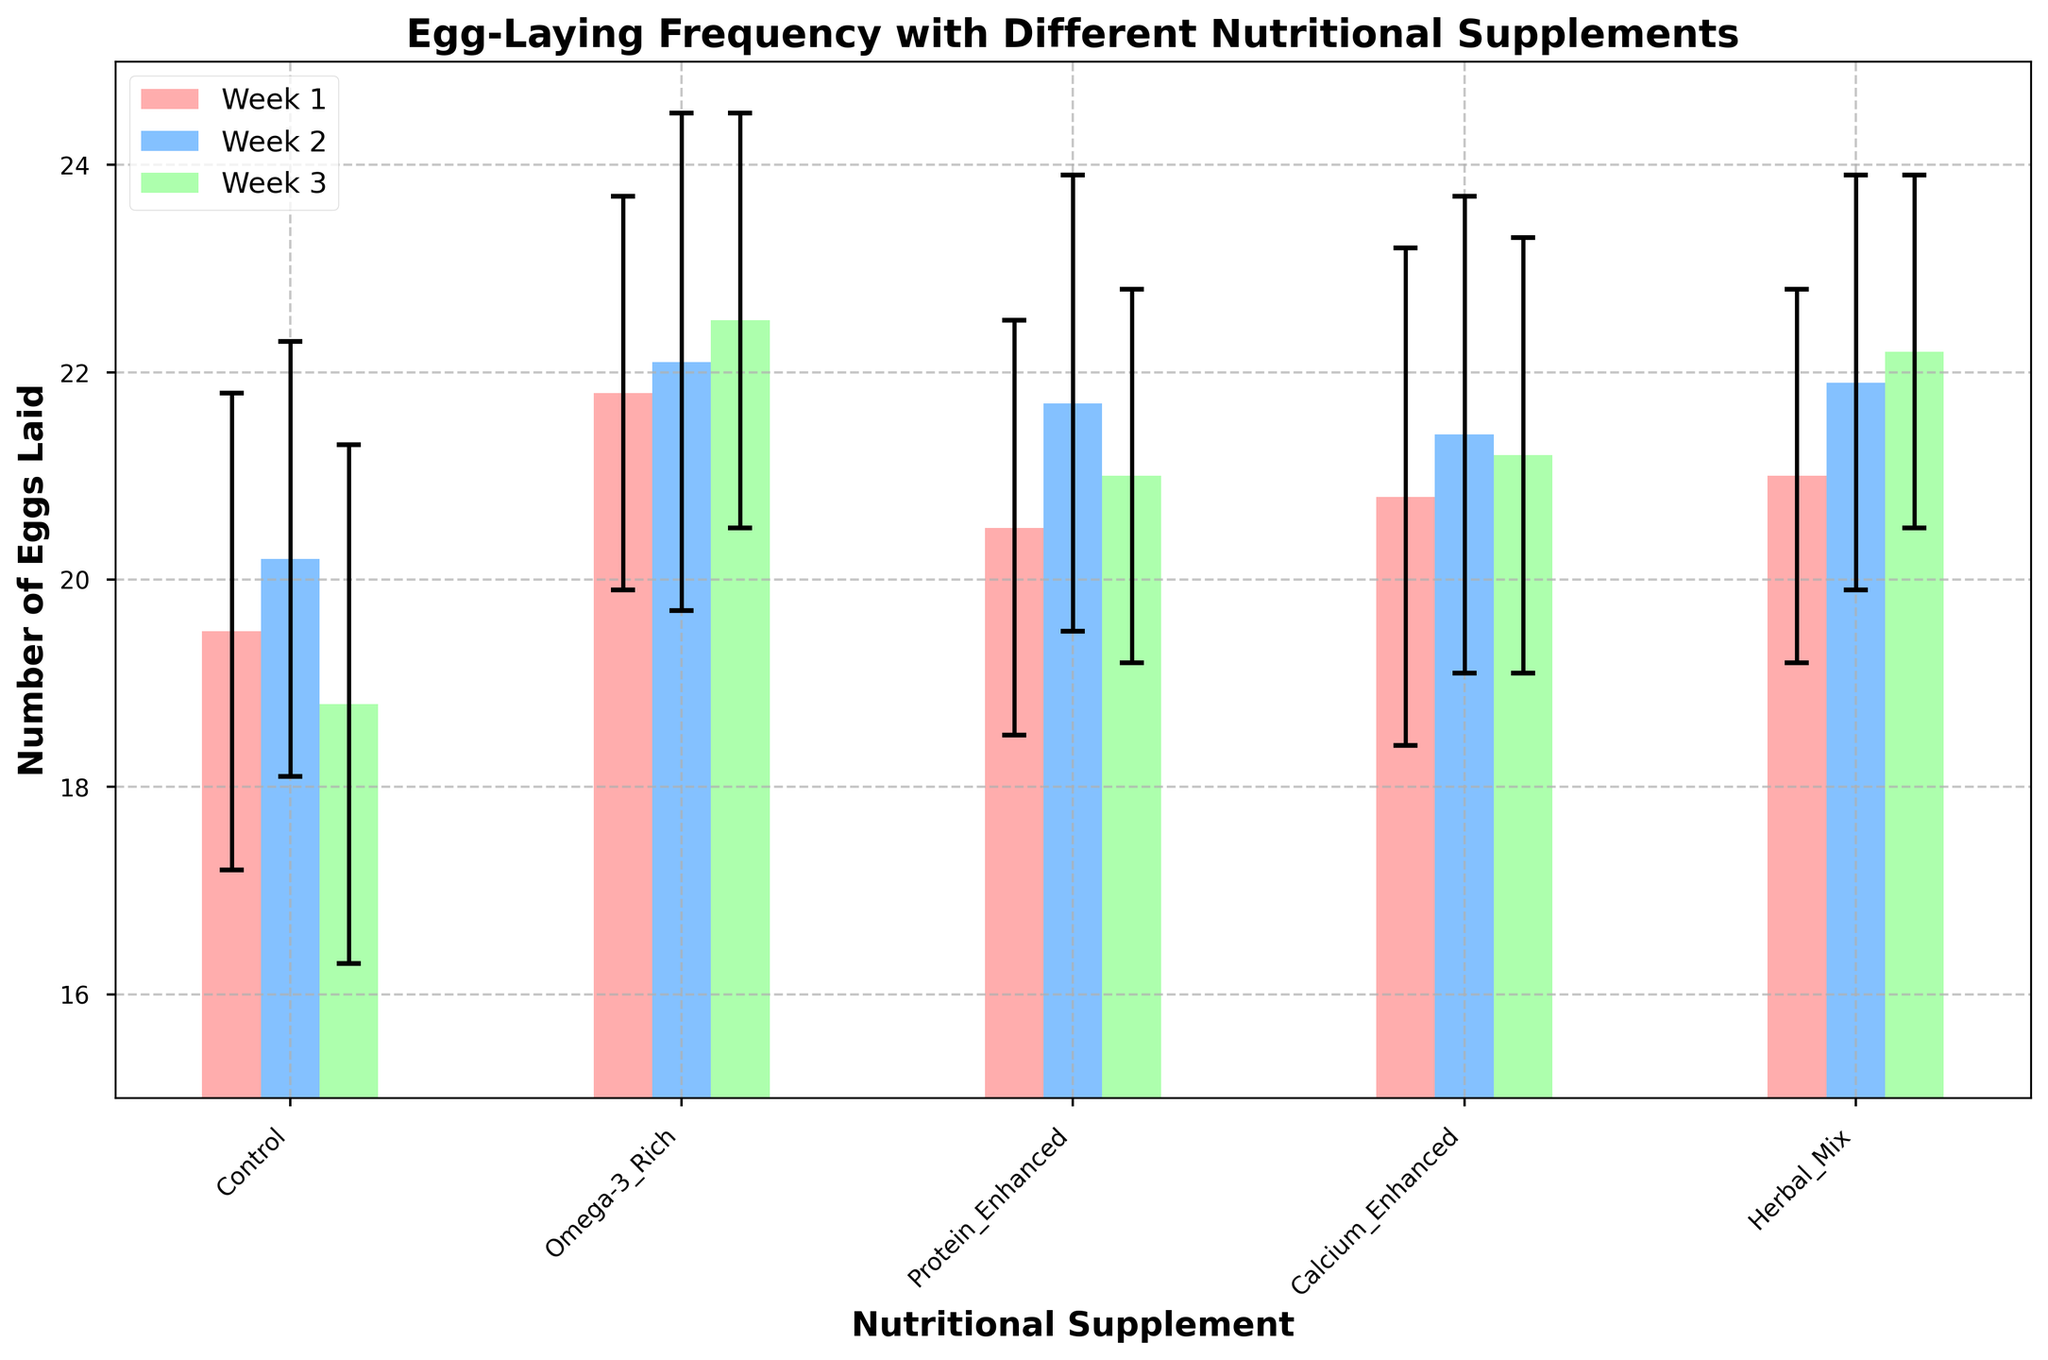What is the title of the figure? The title is displayed at the top of the figure. It provides a summary of what the figure represents.
Answer: Egg-Laying Frequency with Different Nutritional Supplements Which supplement had the lowest average number of eggs laid in Week 1? Locate the bars representing Week 1 for each supplement and identify the bar with the lowest height.
Answer: Control Which nutritional supplement showed an increasing trend of egg-laying frequency from Week 1 to Week 3? Compare the heights of the bars for each week for each supplement. Identify the supplement where bars show a consistent increase.
Answer: Omega-3 Rich What is the average number of eggs laid by the Control group over all three weeks? Sum the number of eggs laid by the Control group for each week and divide by 3. Calculations: (19.5 + 20.2 + 18.8) / 3
Answer: 19.5 What is the difference in the number of eggs laid between the Protein-Enhanced supplement in Week 2 and Week 1? Subtract the number of eggs laid in Week 1 from the number of eggs laid in Week 2 for the Protein-Enhanced supplement. Calculation: 21.7 - 20.5
Answer: 1.2 Among all the supplements, which had the highest standard deviation in Week 3? Locate the error bars (standard deviation) for each supplement in Week 3 and identify the largest one.
Answer: Control Between the Herbal Mix and Calcium Enhanced supplements, which one had more consistent egg-laying (lower standard deviation) in Week 3? Compare the length of the error bars for the Herbal Mix and Calcium Enhanced supplements in Week 3. Identify the shorter error bar.
Answer: Herbal Mix What is the total number of eggs laid by chickens given the Herbal Mix supplement over all three weeks? Sum the number of eggs laid by the Herbal Mix supplement for each week. Calculation: 21.0 + 21.9 + 22.2
Answer: 65.1 Which week had the least variation (lowest standard deviation) for the Omega-3 Rich supplement? Identify the error bars for the Omega-3 Rich supplement for each week and find the smallest one.
Answer: Week 1 How many more eggs did chickens on the Omega-3 Rich supplement lay compared to the Control group in Week 3? Subtract the number of eggs laid in the Control group from the number of eggs laid in the Omega-3 Rich group in Week 3. Calculation: 22.5 - 18.8
Answer: 3.7 